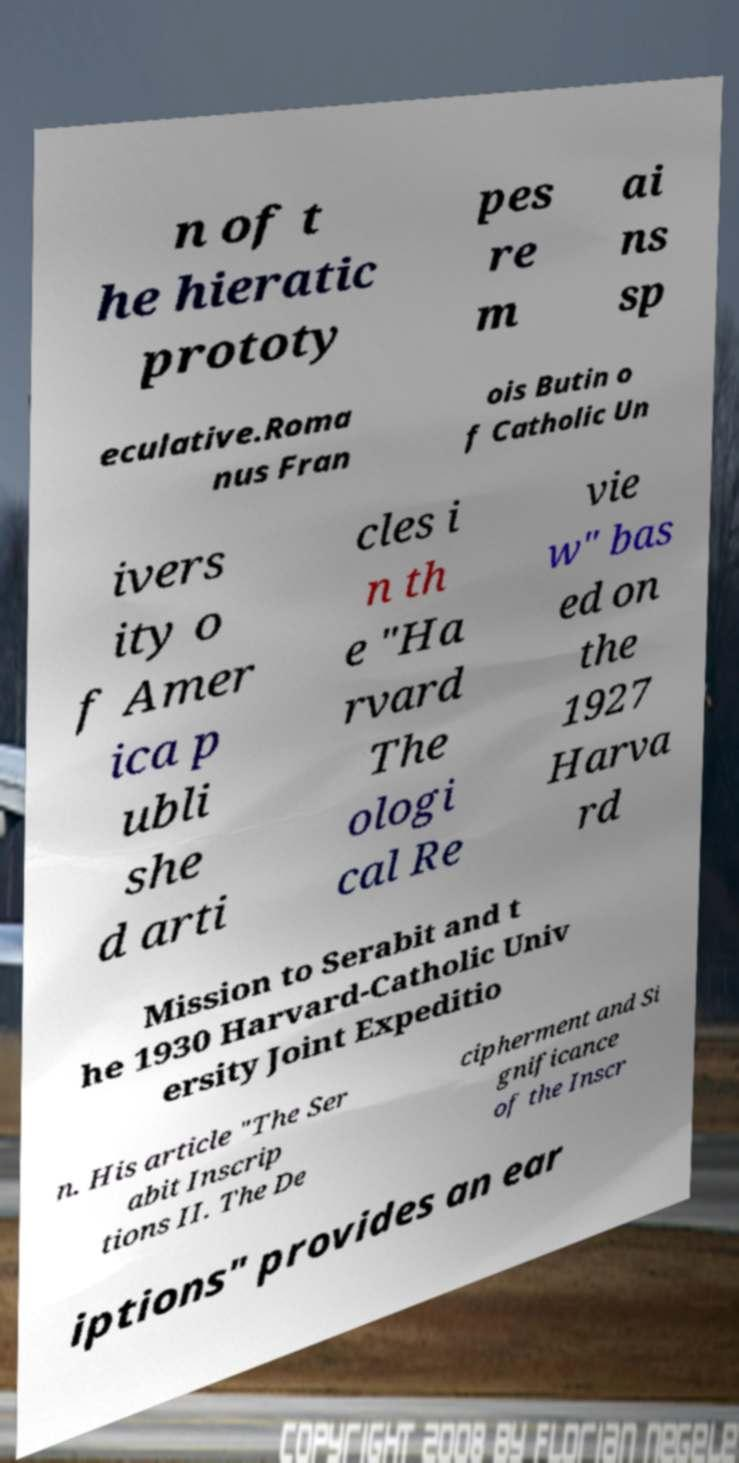There's text embedded in this image that I need extracted. Can you transcribe it verbatim? n of t he hieratic prototy pes re m ai ns sp eculative.Roma nus Fran ois Butin o f Catholic Un ivers ity o f Amer ica p ubli she d arti cles i n th e "Ha rvard The ologi cal Re vie w" bas ed on the 1927 Harva rd Mission to Serabit and t he 1930 Harvard-Catholic Univ ersity Joint Expeditio n. His article "The Ser abit Inscrip tions II. The De cipherment and Si gnificance of the Inscr iptions" provides an ear 